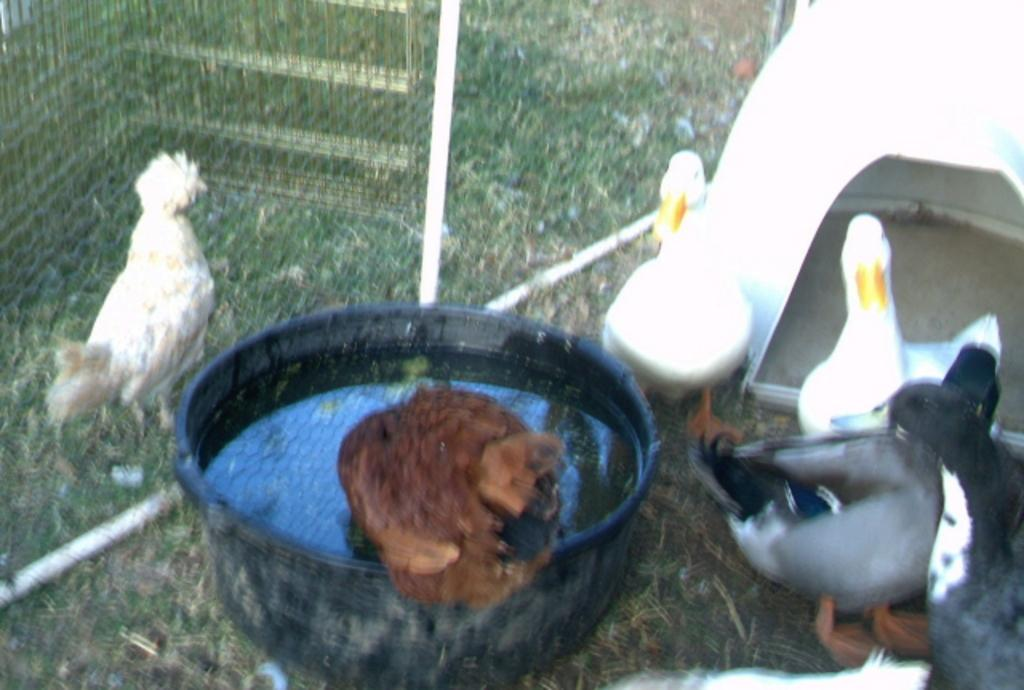What type of animals can be seen in the image? There are ducks and other birds in the image. Where are the birds located in the image? The ducks and other birds are on the ground in the image. What is present in the tray in the image? There is water in a tray in the image. What type of drink is being served to the chickens in the image? There are no chickens or drinks present in the image; it features ducks and other birds near water in a tray. 